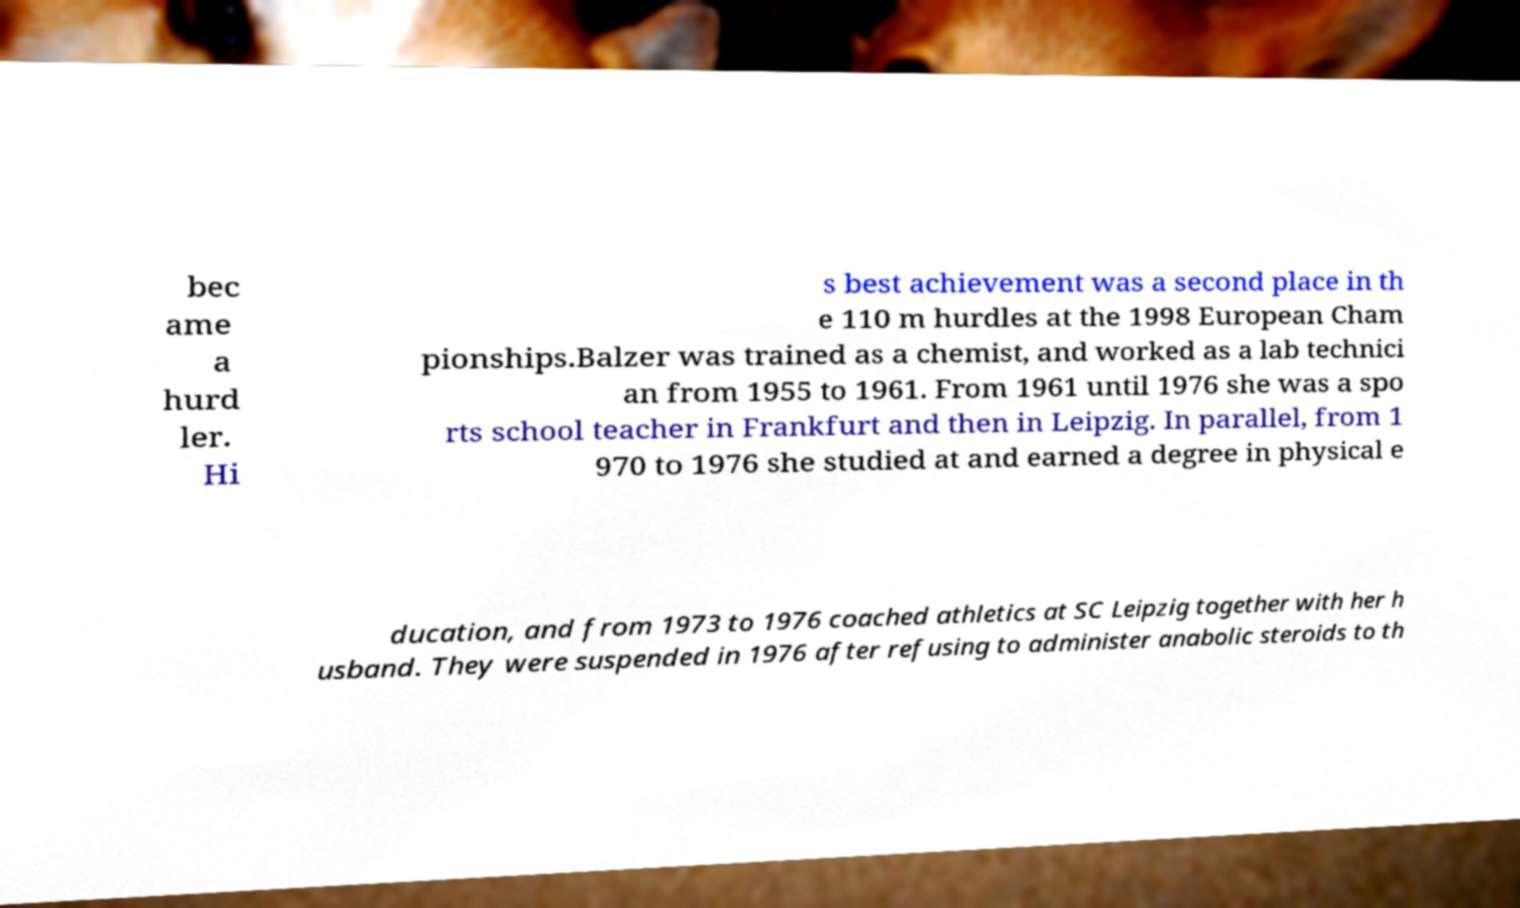Please read and relay the text visible in this image. What does it say? bec ame a hurd ler. Hi s best achievement was a second place in th e 110 m hurdles at the 1998 European Cham pionships.Balzer was trained as a chemist, and worked as a lab technici an from 1955 to 1961. From 1961 until 1976 she was a spo rts school teacher in Frankfurt and then in Leipzig. In parallel, from 1 970 to 1976 she studied at and earned a degree in physical e ducation, and from 1973 to 1976 coached athletics at SC Leipzig together with her h usband. They were suspended in 1976 after refusing to administer anabolic steroids to th 